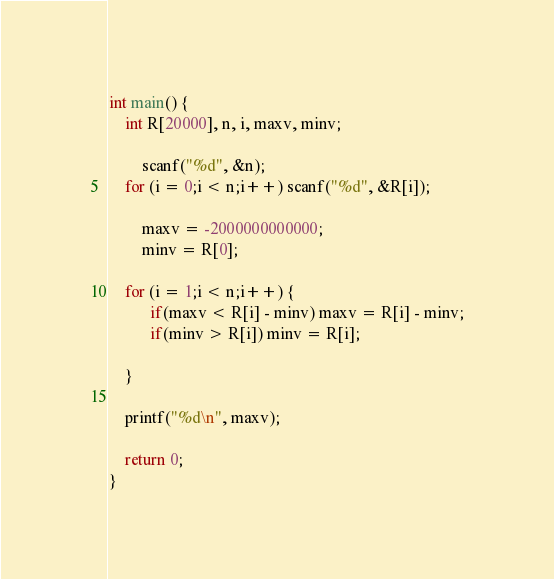Convert code to text. <code><loc_0><loc_0><loc_500><loc_500><_C_>int main() {
	int R[20000], n, i, maxv, minv;
	
        scanf("%d", &n);
	for (i = 0;i < n;i++) scanf("%d", &R[i]);

        maxv = -2000000000000;
        minv = R[0];

	for (i = 1;i < n;i++) {
          if(maxv < R[i] - minv) maxv = R[i] - minv;
          if(minv > R[i]) minv = R[i];

	}

	printf("%d\n", maxv);

	return 0;
}</code> 